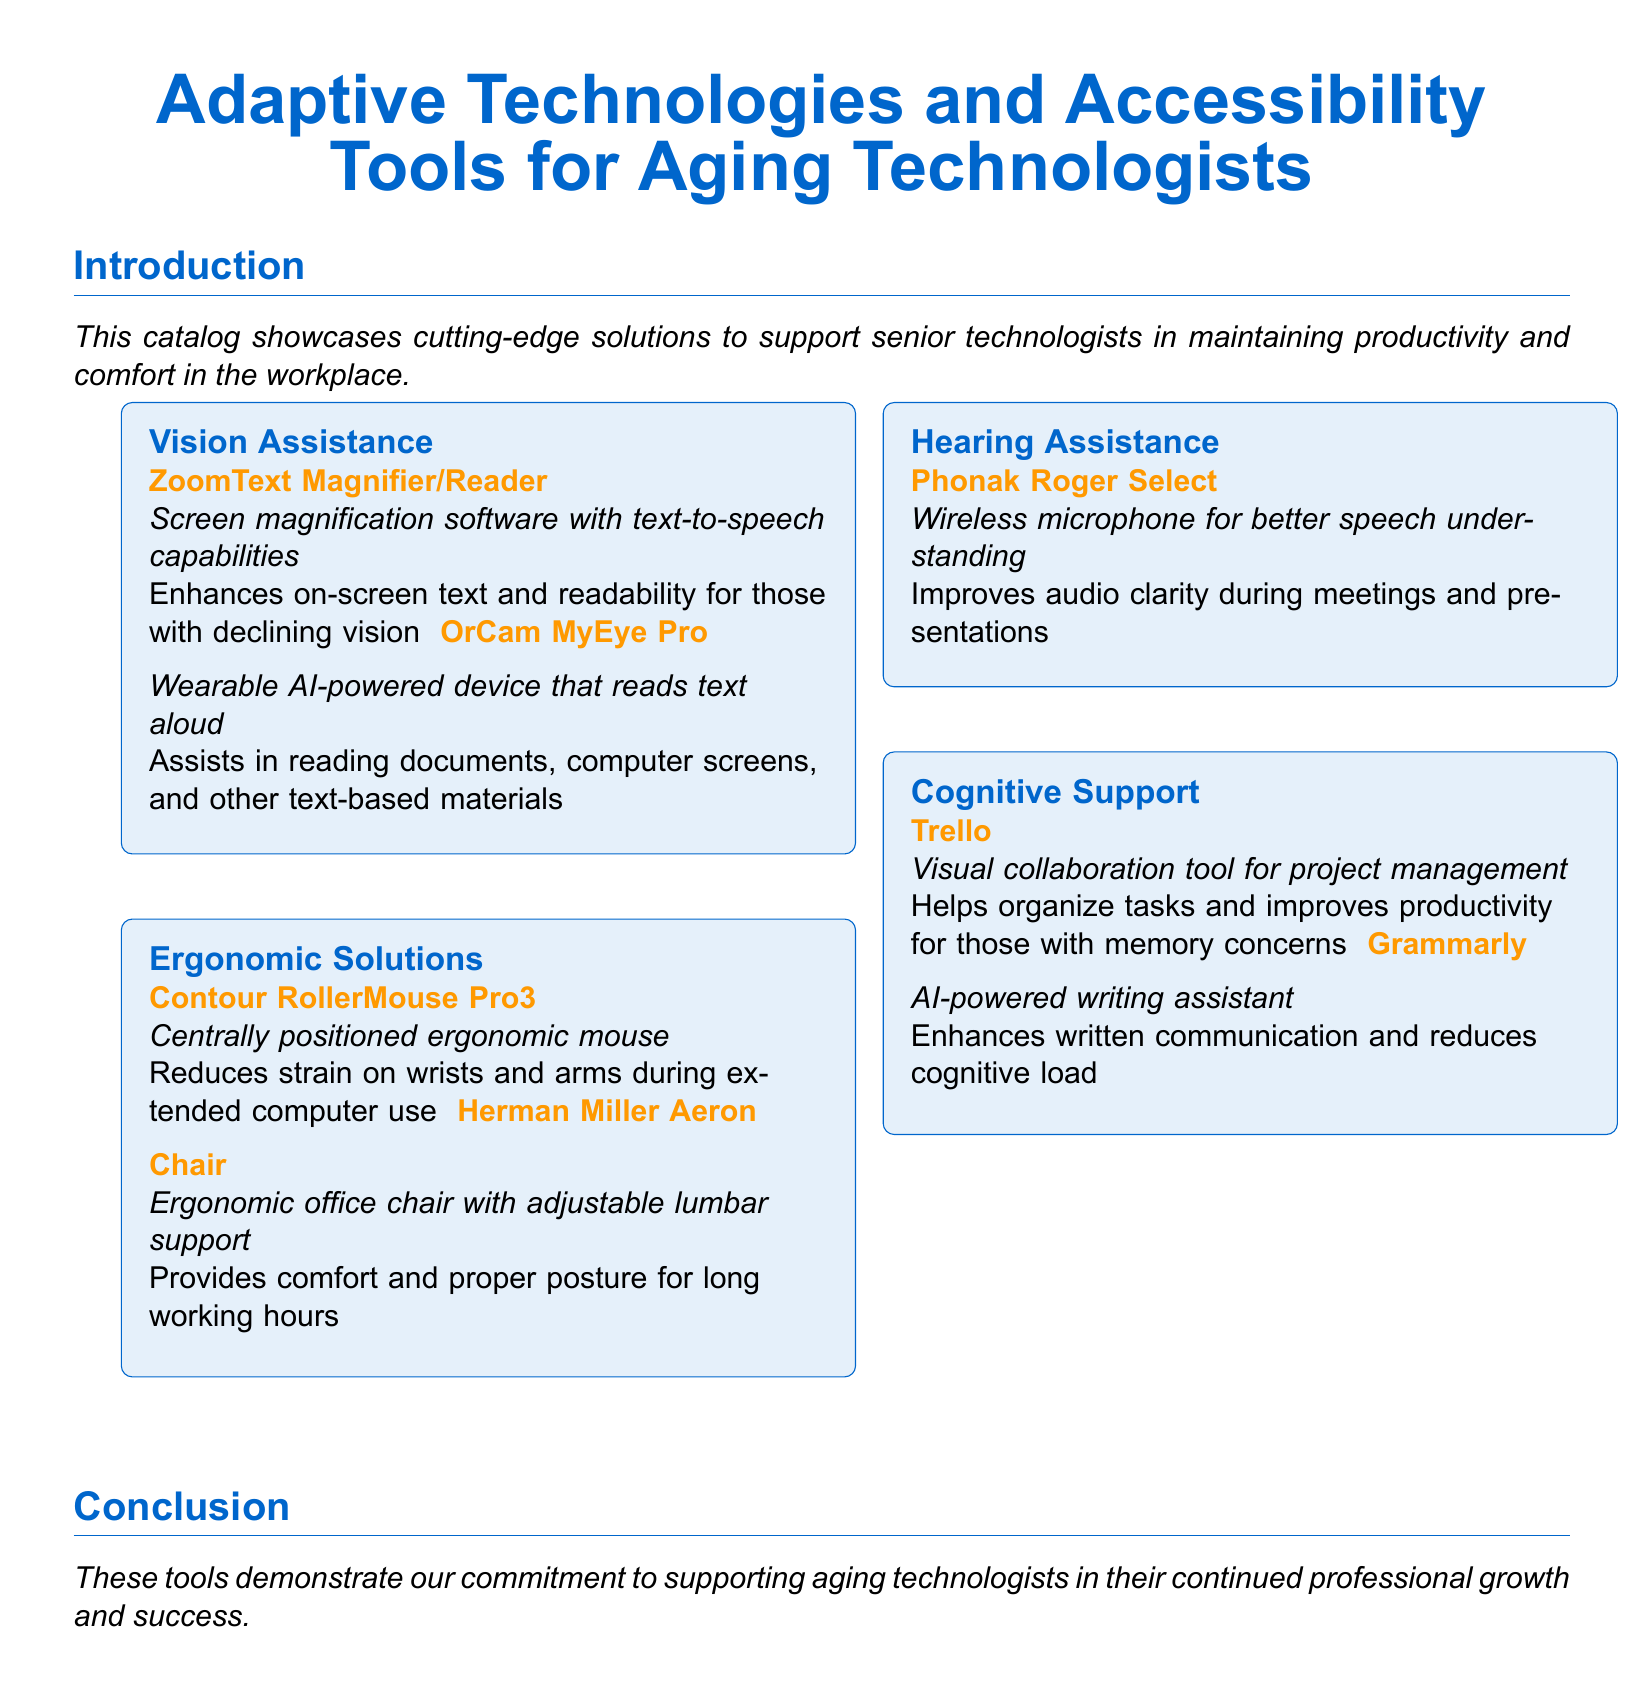What is the title of the catalog? The title of the catalog is stated prominently at the top of the document.
Answer: Adaptive Technologies and Accessibility Tools for Aging Technologists How many categories are listed in the catalog? The categories are listed as separate sections in the document.
Answer: Four What is one example of a vision assistance tool? The document provides specific examples under each category.
Answer: ZoomText Magnifier/Reader What is the purpose of the Trello tool? The document explains the functionality of each tool in relation to aging technologists.
Answer: Helps organize tasks Which ergonomic solution is mentioned for reducing strain during computer use? The catalog provides details on ergonomic products to support aging technologists.
Answer: Contour RollerMouse Pro3 What type of assistance does the Phonak Roger Select provide? This tool's function is specified under the hearing assistance category in the document.
Answer: Hearing Which writing assistant tool is featured in the cognitive support category? The catalog lists specific tools to aid cognitive functions.
Answer: Grammarly What does the OrCam MyEye Pro assist with? The document describes the functionality of the tools in the vision assistance category.
Answer: Reading documents What is emphasized in the conclusion of the catalog? The conclusion summarizes the overall purpose of the tools listed in the catalog.
Answer: Professional growth 